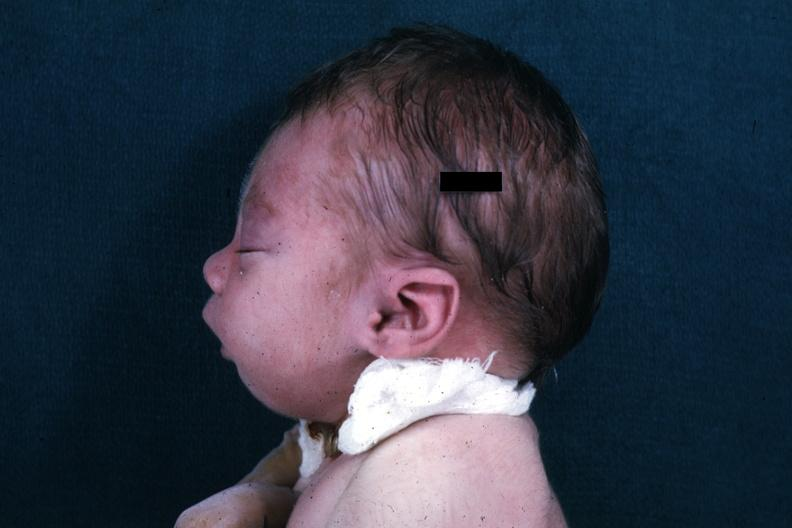do lateral view of infants head showing mandibular lesion?
Answer the question using a single word or phrase. Yes 